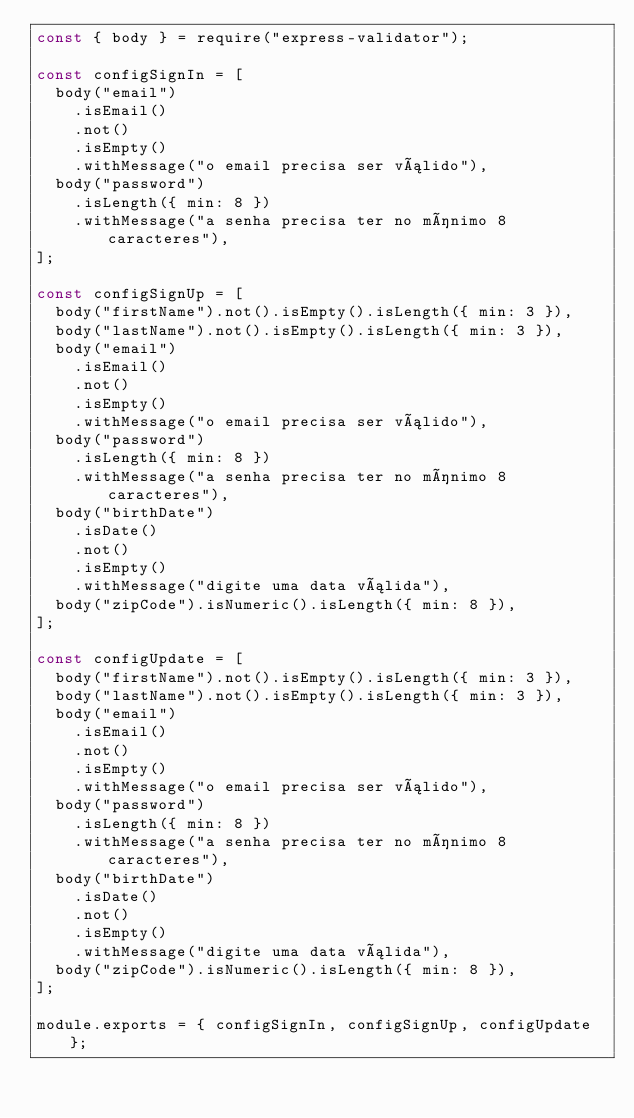Convert code to text. <code><loc_0><loc_0><loc_500><loc_500><_JavaScript_>const { body } = require("express-validator");

const configSignIn = [
  body("email")
    .isEmail()
    .not()
    .isEmpty()
    .withMessage("o email precisa ser válido"),
  body("password")
    .isLength({ min: 8 })
    .withMessage("a senha precisa ter no mínimo 8 caracteres"),
];

const configSignUp = [
  body("firstName").not().isEmpty().isLength({ min: 3 }),
  body("lastName").not().isEmpty().isLength({ min: 3 }),
  body("email")
    .isEmail()
    .not()
    .isEmpty()
    .withMessage("o email precisa ser válido"),
  body("password")
    .isLength({ min: 8 })
    .withMessage("a senha precisa ter no mínimo 8 caracteres"),
  body("birthDate")
    .isDate()
    .not()
    .isEmpty()
    .withMessage("digite uma data válida"),
  body("zipCode").isNumeric().isLength({ min: 8 }),
];

const configUpdate = [
  body("firstName").not().isEmpty().isLength({ min: 3 }),
  body("lastName").not().isEmpty().isLength({ min: 3 }),
  body("email")
    .isEmail()
    .not()
    .isEmpty()
    .withMessage("o email precisa ser válido"),
  body("password")
    .isLength({ min: 8 })
    .withMessage("a senha precisa ter no mínimo 8 caracteres"),
  body("birthDate")
    .isDate()
    .not()
    .isEmpty()
    .withMessage("digite uma data válida"),
  body("zipCode").isNumeric().isLength({ min: 8 }),
];

module.exports = { configSignIn, configSignUp, configUpdate };
</code> 